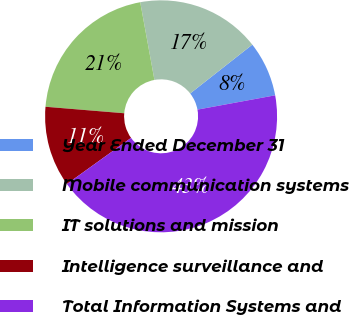Convert chart. <chart><loc_0><loc_0><loc_500><loc_500><pie_chart><fcel>Year Ended December 31<fcel>Mobile communication systems<fcel>IT solutions and mission<fcel>Intelligence surveillance and<fcel>Total Information Systems and<nl><fcel>7.7%<fcel>17.28%<fcel>20.81%<fcel>11.23%<fcel>42.98%<nl></chart> 